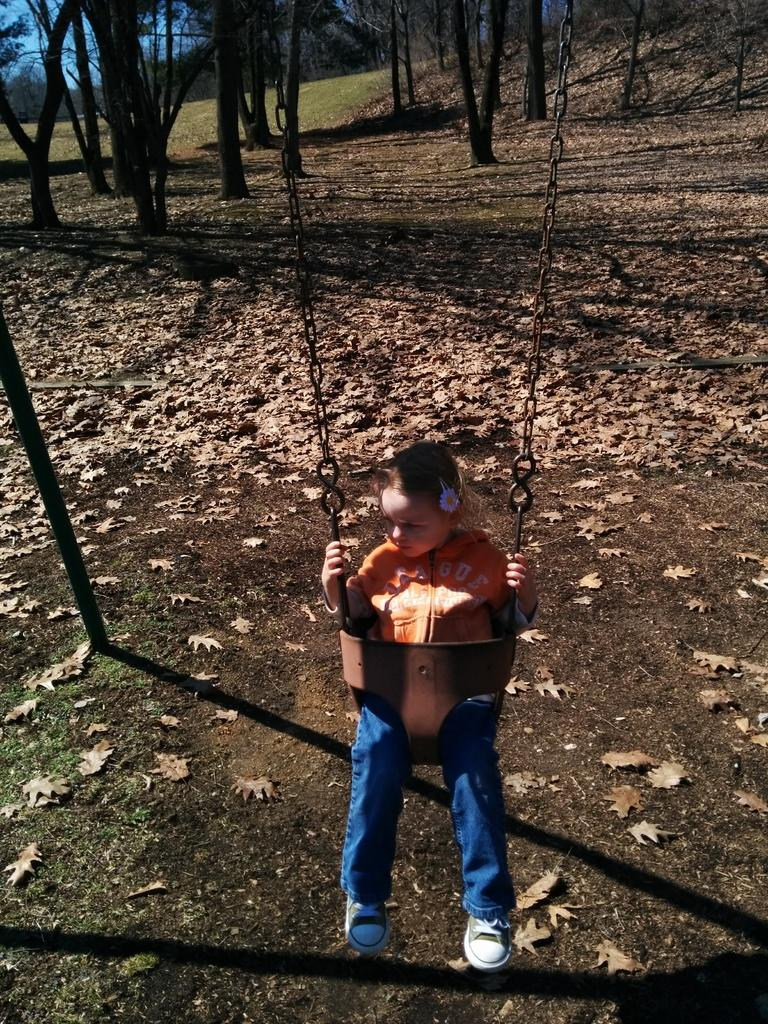What is the girl doing in the image? The girl is sitting on a swing in the image. What is connected to the swing? There is a rod associated with the swing. What can be seen on the ground in the image? Leaves are present on the ground. What is visible in the background of the image? Trees, grass, and the sky are visible in the background of the image. What type of oil is being used to comb the girl's hair in the image? There is no indication in the image that the girl's hair is being combed or that oil is being used. 